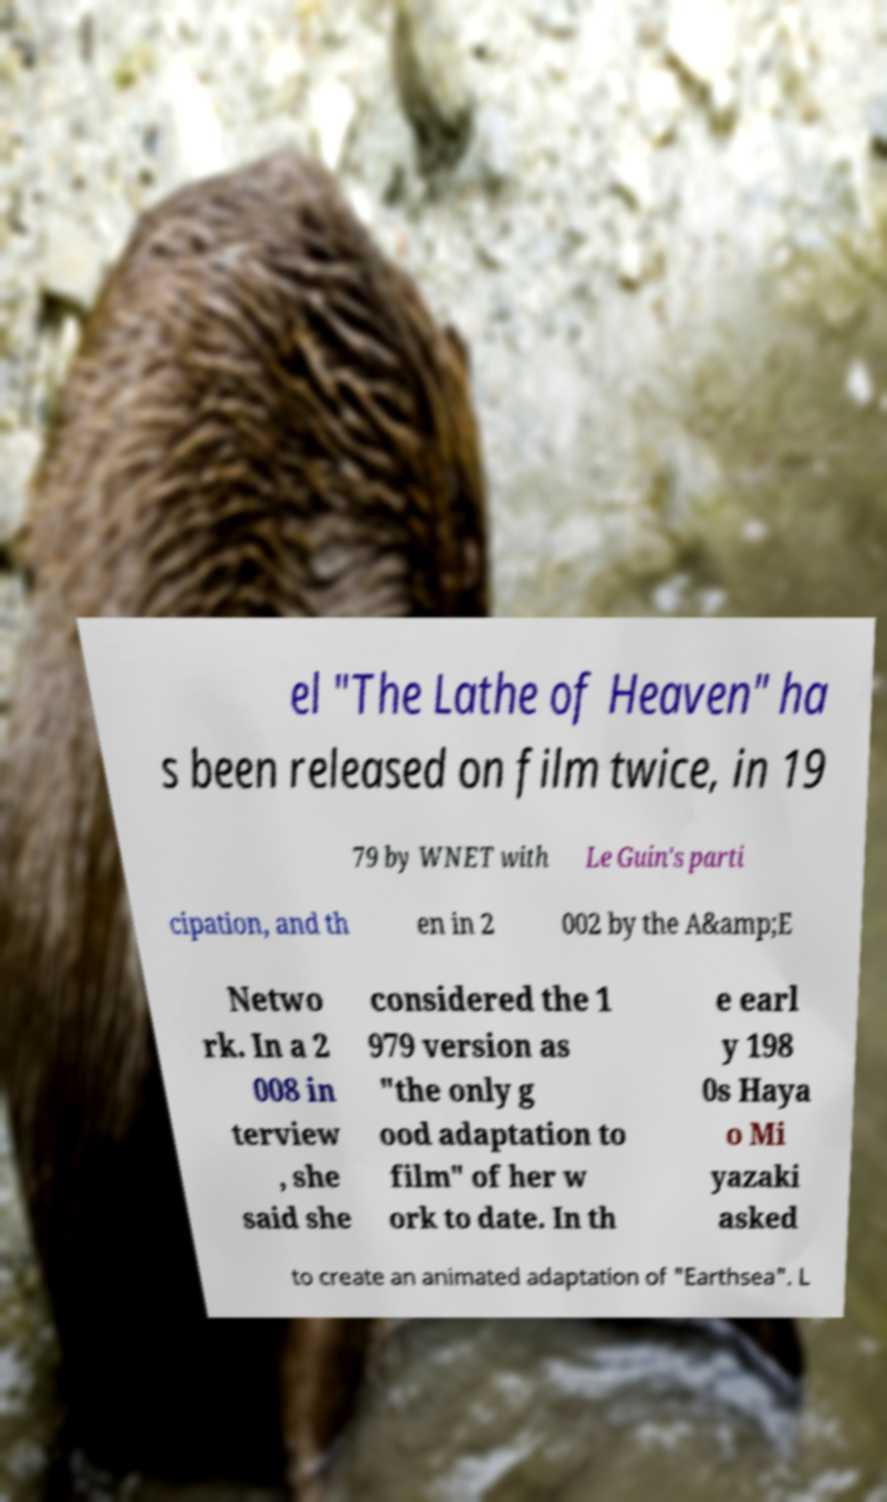Please identify and transcribe the text found in this image. el "The Lathe of Heaven" ha s been released on film twice, in 19 79 by WNET with Le Guin's parti cipation, and th en in 2 002 by the A&amp;E Netwo rk. In a 2 008 in terview , she said she considered the 1 979 version as "the only g ood adaptation to film" of her w ork to date. In th e earl y 198 0s Haya o Mi yazaki asked to create an animated adaptation of "Earthsea". L 